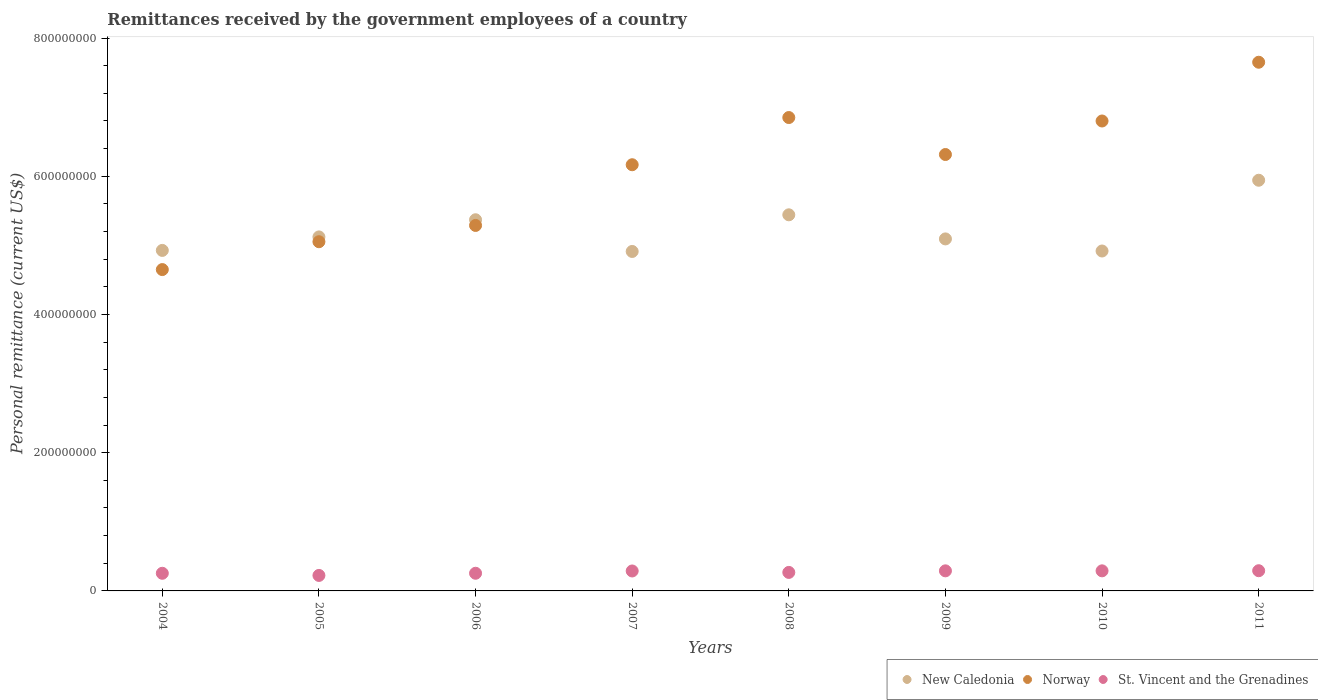How many different coloured dotlines are there?
Keep it short and to the point. 3. Is the number of dotlines equal to the number of legend labels?
Ensure brevity in your answer.  Yes. What is the remittances received by the government employees in New Caledonia in 2005?
Offer a very short reply. 5.12e+08. Across all years, what is the maximum remittances received by the government employees in Norway?
Make the answer very short. 7.65e+08. Across all years, what is the minimum remittances received by the government employees in Norway?
Ensure brevity in your answer.  4.65e+08. What is the total remittances received by the government employees in Norway in the graph?
Your response must be concise. 4.88e+09. What is the difference between the remittances received by the government employees in New Caledonia in 2004 and that in 2006?
Keep it short and to the point. -4.44e+07. What is the difference between the remittances received by the government employees in St. Vincent and the Grenadines in 2011 and the remittances received by the government employees in Norway in 2010?
Make the answer very short. -6.51e+08. What is the average remittances received by the government employees in New Caledonia per year?
Keep it short and to the point. 5.22e+08. In the year 2004, what is the difference between the remittances received by the government employees in New Caledonia and remittances received by the government employees in Norway?
Give a very brief answer. 2.77e+07. What is the ratio of the remittances received by the government employees in New Caledonia in 2008 to that in 2011?
Make the answer very short. 0.92. Is the difference between the remittances received by the government employees in New Caledonia in 2004 and 2009 greater than the difference between the remittances received by the government employees in Norway in 2004 and 2009?
Your answer should be very brief. Yes. What is the difference between the highest and the second highest remittances received by the government employees in St. Vincent and the Grenadines?
Your response must be concise. 1.79e+05. What is the difference between the highest and the lowest remittances received by the government employees in New Caledonia?
Provide a succinct answer. 1.03e+08. In how many years, is the remittances received by the government employees in New Caledonia greater than the average remittances received by the government employees in New Caledonia taken over all years?
Keep it short and to the point. 3. Is the sum of the remittances received by the government employees in Norway in 2007 and 2011 greater than the maximum remittances received by the government employees in New Caledonia across all years?
Offer a very short reply. Yes. Is the remittances received by the government employees in New Caledonia strictly greater than the remittances received by the government employees in St. Vincent and the Grenadines over the years?
Give a very brief answer. Yes. Is the remittances received by the government employees in Norway strictly less than the remittances received by the government employees in New Caledonia over the years?
Your answer should be very brief. No. How many years are there in the graph?
Your response must be concise. 8. What is the difference between two consecutive major ticks on the Y-axis?
Your answer should be very brief. 2.00e+08. Are the values on the major ticks of Y-axis written in scientific E-notation?
Your answer should be compact. No. Does the graph contain any zero values?
Make the answer very short. No. Does the graph contain grids?
Offer a very short reply. No. Where does the legend appear in the graph?
Ensure brevity in your answer.  Bottom right. What is the title of the graph?
Ensure brevity in your answer.  Remittances received by the government employees of a country. Does "Panama" appear as one of the legend labels in the graph?
Offer a very short reply. No. What is the label or title of the X-axis?
Ensure brevity in your answer.  Years. What is the label or title of the Y-axis?
Ensure brevity in your answer.  Personal remittance (current US$). What is the Personal remittance (current US$) of New Caledonia in 2004?
Make the answer very short. 4.93e+08. What is the Personal remittance (current US$) in Norway in 2004?
Keep it short and to the point. 4.65e+08. What is the Personal remittance (current US$) of St. Vincent and the Grenadines in 2004?
Keep it short and to the point. 2.55e+07. What is the Personal remittance (current US$) of New Caledonia in 2005?
Ensure brevity in your answer.  5.12e+08. What is the Personal remittance (current US$) of Norway in 2005?
Provide a short and direct response. 5.05e+08. What is the Personal remittance (current US$) in St. Vincent and the Grenadines in 2005?
Your response must be concise. 2.24e+07. What is the Personal remittance (current US$) of New Caledonia in 2006?
Provide a short and direct response. 5.37e+08. What is the Personal remittance (current US$) of Norway in 2006?
Give a very brief answer. 5.29e+08. What is the Personal remittance (current US$) in St. Vincent and the Grenadines in 2006?
Your response must be concise. 2.56e+07. What is the Personal remittance (current US$) of New Caledonia in 2007?
Offer a very short reply. 4.91e+08. What is the Personal remittance (current US$) of Norway in 2007?
Your response must be concise. 6.17e+08. What is the Personal remittance (current US$) of St. Vincent and the Grenadines in 2007?
Your response must be concise. 2.89e+07. What is the Personal remittance (current US$) in New Caledonia in 2008?
Offer a very short reply. 5.44e+08. What is the Personal remittance (current US$) of Norway in 2008?
Your answer should be very brief. 6.85e+08. What is the Personal remittance (current US$) of St. Vincent and the Grenadines in 2008?
Your answer should be very brief. 2.68e+07. What is the Personal remittance (current US$) in New Caledonia in 2009?
Provide a succinct answer. 5.09e+08. What is the Personal remittance (current US$) in Norway in 2009?
Your answer should be compact. 6.31e+08. What is the Personal remittance (current US$) of St. Vincent and the Grenadines in 2009?
Keep it short and to the point. 2.91e+07. What is the Personal remittance (current US$) of New Caledonia in 2010?
Offer a terse response. 4.92e+08. What is the Personal remittance (current US$) of Norway in 2010?
Make the answer very short. 6.80e+08. What is the Personal remittance (current US$) of St. Vincent and the Grenadines in 2010?
Offer a terse response. 2.91e+07. What is the Personal remittance (current US$) of New Caledonia in 2011?
Your answer should be very brief. 5.94e+08. What is the Personal remittance (current US$) of Norway in 2011?
Your answer should be compact. 7.65e+08. What is the Personal remittance (current US$) in St. Vincent and the Grenadines in 2011?
Provide a succinct answer. 2.92e+07. Across all years, what is the maximum Personal remittance (current US$) of New Caledonia?
Give a very brief answer. 5.94e+08. Across all years, what is the maximum Personal remittance (current US$) in Norway?
Your answer should be compact. 7.65e+08. Across all years, what is the maximum Personal remittance (current US$) in St. Vincent and the Grenadines?
Make the answer very short. 2.92e+07. Across all years, what is the minimum Personal remittance (current US$) of New Caledonia?
Keep it short and to the point. 4.91e+08. Across all years, what is the minimum Personal remittance (current US$) in Norway?
Ensure brevity in your answer.  4.65e+08. Across all years, what is the minimum Personal remittance (current US$) of St. Vincent and the Grenadines?
Your answer should be compact. 2.24e+07. What is the total Personal remittance (current US$) of New Caledonia in the graph?
Keep it short and to the point. 4.17e+09. What is the total Personal remittance (current US$) in Norway in the graph?
Offer a very short reply. 4.88e+09. What is the total Personal remittance (current US$) in St. Vincent and the Grenadines in the graph?
Give a very brief answer. 2.16e+08. What is the difference between the Personal remittance (current US$) of New Caledonia in 2004 and that in 2005?
Provide a short and direct response. -1.95e+07. What is the difference between the Personal remittance (current US$) in Norway in 2004 and that in 2005?
Ensure brevity in your answer.  -4.03e+07. What is the difference between the Personal remittance (current US$) of St. Vincent and the Grenadines in 2004 and that in 2005?
Your answer should be compact. 3.10e+06. What is the difference between the Personal remittance (current US$) of New Caledonia in 2004 and that in 2006?
Offer a terse response. -4.44e+07. What is the difference between the Personal remittance (current US$) of Norway in 2004 and that in 2006?
Provide a succinct answer. -6.39e+07. What is the difference between the Personal remittance (current US$) in St. Vincent and the Grenadines in 2004 and that in 2006?
Your response must be concise. -3.93e+04. What is the difference between the Personal remittance (current US$) of New Caledonia in 2004 and that in 2007?
Keep it short and to the point. 1.52e+06. What is the difference between the Personal remittance (current US$) in Norway in 2004 and that in 2007?
Give a very brief answer. -1.52e+08. What is the difference between the Personal remittance (current US$) of St. Vincent and the Grenadines in 2004 and that in 2007?
Provide a succinct answer. -3.35e+06. What is the difference between the Personal remittance (current US$) in New Caledonia in 2004 and that in 2008?
Ensure brevity in your answer.  -5.15e+07. What is the difference between the Personal remittance (current US$) of Norway in 2004 and that in 2008?
Your answer should be compact. -2.20e+08. What is the difference between the Personal remittance (current US$) of St. Vincent and the Grenadines in 2004 and that in 2008?
Your response must be concise. -1.26e+06. What is the difference between the Personal remittance (current US$) of New Caledonia in 2004 and that in 2009?
Provide a short and direct response. -1.66e+07. What is the difference between the Personal remittance (current US$) in Norway in 2004 and that in 2009?
Keep it short and to the point. -1.66e+08. What is the difference between the Personal remittance (current US$) in St. Vincent and the Grenadines in 2004 and that in 2009?
Provide a short and direct response. -3.54e+06. What is the difference between the Personal remittance (current US$) of New Caledonia in 2004 and that in 2010?
Provide a short and direct response. 8.64e+05. What is the difference between the Personal remittance (current US$) of Norway in 2004 and that in 2010?
Provide a short and direct response. -2.15e+08. What is the difference between the Personal remittance (current US$) in St. Vincent and the Grenadines in 2004 and that in 2010?
Give a very brief answer. -3.54e+06. What is the difference between the Personal remittance (current US$) in New Caledonia in 2004 and that in 2011?
Make the answer very short. -1.02e+08. What is the difference between the Personal remittance (current US$) in Norway in 2004 and that in 2011?
Your answer should be compact. -3.00e+08. What is the difference between the Personal remittance (current US$) of St. Vincent and the Grenadines in 2004 and that in 2011?
Ensure brevity in your answer.  -3.72e+06. What is the difference between the Personal remittance (current US$) in New Caledonia in 2005 and that in 2006?
Your answer should be very brief. -2.48e+07. What is the difference between the Personal remittance (current US$) in Norway in 2005 and that in 2006?
Offer a very short reply. -2.36e+07. What is the difference between the Personal remittance (current US$) in St. Vincent and the Grenadines in 2005 and that in 2006?
Your answer should be very brief. -3.14e+06. What is the difference between the Personal remittance (current US$) in New Caledonia in 2005 and that in 2007?
Offer a terse response. 2.10e+07. What is the difference between the Personal remittance (current US$) in Norway in 2005 and that in 2007?
Keep it short and to the point. -1.11e+08. What is the difference between the Personal remittance (current US$) of St. Vincent and the Grenadines in 2005 and that in 2007?
Provide a succinct answer. -6.45e+06. What is the difference between the Personal remittance (current US$) of New Caledonia in 2005 and that in 2008?
Offer a terse response. -3.20e+07. What is the difference between the Personal remittance (current US$) in Norway in 2005 and that in 2008?
Ensure brevity in your answer.  -1.80e+08. What is the difference between the Personal remittance (current US$) of St. Vincent and the Grenadines in 2005 and that in 2008?
Give a very brief answer. -4.36e+06. What is the difference between the Personal remittance (current US$) in New Caledonia in 2005 and that in 2009?
Your answer should be compact. 2.88e+06. What is the difference between the Personal remittance (current US$) in Norway in 2005 and that in 2009?
Keep it short and to the point. -1.26e+08. What is the difference between the Personal remittance (current US$) in St. Vincent and the Grenadines in 2005 and that in 2009?
Your answer should be very brief. -6.64e+06. What is the difference between the Personal remittance (current US$) in New Caledonia in 2005 and that in 2010?
Keep it short and to the point. 2.04e+07. What is the difference between the Personal remittance (current US$) of Norway in 2005 and that in 2010?
Your answer should be very brief. -1.75e+08. What is the difference between the Personal remittance (current US$) of St. Vincent and the Grenadines in 2005 and that in 2010?
Provide a succinct answer. -6.64e+06. What is the difference between the Personal remittance (current US$) in New Caledonia in 2005 and that in 2011?
Your answer should be compact. -8.20e+07. What is the difference between the Personal remittance (current US$) in Norway in 2005 and that in 2011?
Provide a short and direct response. -2.60e+08. What is the difference between the Personal remittance (current US$) in St. Vincent and the Grenadines in 2005 and that in 2011?
Keep it short and to the point. -6.82e+06. What is the difference between the Personal remittance (current US$) of New Caledonia in 2006 and that in 2007?
Offer a terse response. 4.59e+07. What is the difference between the Personal remittance (current US$) in Norway in 2006 and that in 2007?
Offer a terse response. -8.78e+07. What is the difference between the Personal remittance (current US$) in St. Vincent and the Grenadines in 2006 and that in 2007?
Give a very brief answer. -3.31e+06. What is the difference between the Personal remittance (current US$) of New Caledonia in 2006 and that in 2008?
Offer a terse response. -7.16e+06. What is the difference between the Personal remittance (current US$) of Norway in 2006 and that in 2008?
Your answer should be compact. -1.56e+08. What is the difference between the Personal remittance (current US$) of St. Vincent and the Grenadines in 2006 and that in 2008?
Provide a succinct answer. -1.22e+06. What is the difference between the Personal remittance (current US$) in New Caledonia in 2006 and that in 2009?
Offer a terse response. 2.77e+07. What is the difference between the Personal remittance (current US$) in Norway in 2006 and that in 2009?
Your answer should be compact. -1.03e+08. What is the difference between the Personal remittance (current US$) in St. Vincent and the Grenadines in 2006 and that in 2009?
Ensure brevity in your answer.  -3.50e+06. What is the difference between the Personal remittance (current US$) of New Caledonia in 2006 and that in 2010?
Provide a short and direct response. 4.52e+07. What is the difference between the Personal remittance (current US$) of Norway in 2006 and that in 2010?
Provide a short and direct response. -1.51e+08. What is the difference between the Personal remittance (current US$) in St. Vincent and the Grenadines in 2006 and that in 2010?
Keep it short and to the point. -3.50e+06. What is the difference between the Personal remittance (current US$) in New Caledonia in 2006 and that in 2011?
Provide a short and direct response. -5.72e+07. What is the difference between the Personal remittance (current US$) of Norway in 2006 and that in 2011?
Offer a terse response. -2.36e+08. What is the difference between the Personal remittance (current US$) of St. Vincent and the Grenadines in 2006 and that in 2011?
Offer a terse response. -3.68e+06. What is the difference between the Personal remittance (current US$) in New Caledonia in 2007 and that in 2008?
Provide a short and direct response. -5.30e+07. What is the difference between the Personal remittance (current US$) of Norway in 2007 and that in 2008?
Your answer should be very brief. -6.83e+07. What is the difference between the Personal remittance (current US$) of St. Vincent and the Grenadines in 2007 and that in 2008?
Make the answer very short. 2.09e+06. What is the difference between the Personal remittance (current US$) in New Caledonia in 2007 and that in 2009?
Provide a short and direct response. -1.82e+07. What is the difference between the Personal remittance (current US$) of Norway in 2007 and that in 2009?
Give a very brief answer. -1.48e+07. What is the difference between the Personal remittance (current US$) of St. Vincent and the Grenadines in 2007 and that in 2009?
Provide a succinct answer. -1.92e+05. What is the difference between the Personal remittance (current US$) in New Caledonia in 2007 and that in 2010?
Your answer should be compact. -6.58e+05. What is the difference between the Personal remittance (current US$) of Norway in 2007 and that in 2010?
Your answer should be very brief. -6.33e+07. What is the difference between the Personal remittance (current US$) of St. Vincent and the Grenadines in 2007 and that in 2010?
Your answer should be compact. -1.90e+05. What is the difference between the Personal remittance (current US$) in New Caledonia in 2007 and that in 2011?
Offer a terse response. -1.03e+08. What is the difference between the Personal remittance (current US$) of Norway in 2007 and that in 2011?
Your answer should be very brief. -1.48e+08. What is the difference between the Personal remittance (current US$) in St. Vincent and the Grenadines in 2007 and that in 2011?
Offer a very short reply. -3.71e+05. What is the difference between the Personal remittance (current US$) in New Caledonia in 2008 and that in 2009?
Your answer should be compact. 3.49e+07. What is the difference between the Personal remittance (current US$) in Norway in 2008 and that in 2009?
Provide a succinct answer. 5.35e+07. What is the difference between the Personal remittance (current US$) in St. Vincent and the Grenadines in 2008 and that in 2009?
Provide a succinct answer. -2.28e+06. What is the difference between the Personal remittance (current US$) of New Caledonia in 2008 and that in 2010?
Your answer should be very brief. 5.24e+07. What is the difference between the Personal remittance (current US$) of Norway in 2008 and that in 2010?
Your answer should be very brief. 5.00e+06. What is the difference between the Personal remittance (current US$) of St. Vincent and the Grenadines in 2008 and that in 2010?
Your answer should be very brief. -2.28e+06. What is the difference between the Personal remittance (current US$) in New Caledonia in 2008 and that in 2011?
Ensure brevity in your answer.  -5.00e+07. What is the difference between the Personal remittance (current US$) of Norway in 2008 and that in 2011?
Offer a terse response. -8.00e+07. What is the difference between the Personal remittance (current US$) in St. Vincent and the Grenadines in 2008 and that in 2011?
Give a very brief answer. -2.46e+06. What is the difference between the Personal remittance (current US$) of New Caledonia in 2009 and that in 2010?
Ensure brevity in your answer.  1.75e+07. What is the difference between the Personal remittance (current US$) in Norway in 2009 and that in 2010?
Ensure brevity in your answer.  -4.85e+07. What is the difference between the Personal remittance (current US$) in St. Vincent and the Grenadines in 2009 and that in 2010?
Offer a terse response. 1473.7. What is the difference between the Personal remittance (current US$) of New Caledonia in 2009 and that in 2011?
Your response must be concise. -8.49e+07. What is the difference between the Personal remittance (current US$) of Norway in 2009 and that in 2011?
Your answer should be very brief. -1.34e+08. What is the difference between the Personal remittance (current US$) of St. Vincent and the Grenadines in 2009 and that in 2011?
Your answer should be compact. -1.79e+05. What is the difference between the Personal remittance (current US$) of New Caledonia in 2010 and that in 2011?
Your answer should be compact. -1.02e+08. What is the difference between the Personal remittance (current US$) of Norway in 2010 and that in 2011?
Offer a very short reply. -8.50e+07. What is the difference between the Personal remittance (current US$) in St. Vincent and the Grenadines in 2010 and that in 2011?
Offer a terse response. -1.81e+05. What is the difference between the Personal remittance (current US$) in New Caledonia in 2004 and the Personal remittance (current US$) in Norway in 2005?
Keep it short and to the point. -1.26e+07. What is the difference between the Personal remittance (current US$) of New Caledonia in 2004 and the Personal remittance (current US$) of St. Vincent and the Grenadines in 2005?
Keep it short and to the point. 4.70e+08. What is the difference between the Personal remittance (current US$) in Norway in 2004 and the Personal remittance (current US$) in St. Vincent and the Grenadines in 2005?
Offer a very short reply. 4.43e+08. What is the difference between the Personal remittance (current US$) of New Caledonia in 2004 and the Personal remittance (current US$) of Norway in 2006?
Offer a very short reply. -3.61e+07. What is the difference between the Personal remittance (current US$) in New Caledonia in 2004 and the Personal remittance (current US$) in St. Vincent and the Grenadines in 2006?
Your answer should be compact. 4.67e+08. What is the difference between the Personal remittance (current US$) in Norway in 2004 and the Personal remittance (current US$) in St. Vincent and the Grenadines in 2006?
Offer a terse response. 4.39e+08. What is the difference between the Personal remittance (current US$) in New Caledonia in 2004 and the Personal remittance (current US$) in Norway in 2007?
Make the answer very short. -1.24e+08. What is the difference between the Personal remittance (current US$) of New Caledonia in 2004 and the Personal remittance (current US$) of St. Vincent and the Grenadines in 2007?
Offer a terse response. 4.64e+08. What is the difference between the Personal remittance (current US$) in Norway in 2004 and the Personal remittance (current US$) in St. Vincent and the Grenadines in 2007?
Give a very brief answer. 4.36e+08. What is the difference between the Personal remittance (current US$) of New Caledonia in 2004 and the Personal remittance (current US$) of Norway in 2008?
Provide a succinct answer. -1.92e+08. What is the difference between the Personal remittance (current US$) in New Caledonia in 2004 and the Personal remittance (current US$) in St. Vincent and the Grenadines in 2008?
Provide a short and direct response. 4.66e+08. What is the difference between the Personal remittance (current US$) of Norway in 2004 and the Personal remittance (current US$) of St. Vincent and the Grenadines in 2008?
Your response must be concise. 4.38e+08. What is the difference between the Personal remittance (current US$) of New Caledonia in 2004 and the Personal remittance (current US$) of Norway in 2009?
Provide a short and direct response. -1.39e+08. What is the difference between the Personal remittance (current US$) in New Caledonia in 2004 and the Personal remittance (current US$) in St. Vincent and the Grenadines in 2009?
Provide a short and direct response. 4.64e+08. What is the difference between the Personal remittance (current US$) of Norway in 2004 and the Personal remittance (current US$) of St. Vincent and the Grenadines in 2009?
Your answer should be very brief. 4.36e+08. What is the difference between the Personal remittance (current US$) in New Caledonia in 2004 and the Personal remittance (current US$) in Norway in 2010?
Provide a succinct answer. -1.87e+08. What is the difference between the Personal remittance (current US$) in New Caledonia in 2004 and the Personal remittance (current US$) in St. Vincent and the Grenadines in 2010?
Offer a very short reply. 4.64e+08. What is the difference between the Personal remittance (current US$) of Norway in 2004 and the Personal remittance (current US$) of St. Vincent and the Grenadines in 2010?
Make the answer very short. 4.36e+08. What is the difference between the Personal remittance (current US$) of New Caledonia in 2004 and the Personal remittance (current US$) of Norway in 2011?
Ensure brevity in your answer.  -2.72e+08. What is the difference between the Personal remittance (current US$) in New Caledonia in 2004 and the Personal remittance (current US$) in St. Vincent and the Grenadines in 2011?
Your response must be concise. 4.63e+08. What is the difference between the Personal remittance (current US$) of Norway in 2004 and the Personal remittance (current US$) of St. Vincent and the Grenadines in 2011?
Keep it short and to the point. 4.36e+08. What is the difference between the Personal remittance (current US$) in New Caledonia in 2005 and the Personal remittance (current US$) in Norway in 2006?
Make the answer very short. -1.66e+07. What is the difference between the Personal remittance (current US$) of New Caledonia in 2005 and the Personal remittance (current US$) of St. Vincent and the Grenadines in 2006?
Ensure brevity in your answer.  4.87e+08. What is the difference between the Personal remittance (current US$) in Norway in 2005 and the Personal remittance (current US$) in St. Vincent and the Grenadines in 2006?
Your answer should be compact. 4.80e+08. What is the difference between the Personal remittance (current US$) of New Caledonia in 2005 and the Personal remittance (current US$) of Norway in 2007?
Your answer should be very brief. -1.04e+08. What is the difference between the Personal remittance (current US$) in New Caledonia in 2005 and the Personal remittance (current US$) in St. Vincent and the Grenadines in 2007?
Provide a short and direct response. 4.83e+08. What is the difference between the Personal remittance (current US$) of Norway in 2005 and the Personal remittance (current US$) of St. Vincent and the Grenadines in 2007?
Your answer should be compact. 4.76e+08. What is the difference between the Personal remittance (current US$) in New Caledonia in 2005 and the Personal remittance (current US$) in Norway in 2008?
Give a very brief answer. -1.73e+08. What is the difference between the Personal remittance (current US$) in New Caledonia in 2005 and the Personal remittance (current US$) in St. Vincent and the Grenadines in 2008?
Offer a terse response. 4.85e+08. What is the difference between the Personal remittance (current US$) of Norway in 2005 and the Personal remittance (current US$) of St. Vincent and the Grenadines in 2008?
Provide a succinct answer. 4.79e+08. What is the difference between the Personal remittance (current US$) in New Caledonia in 2005 and the Personal remittance (current US$) in Norway in 2009?
Offer a very short reply. -1.19e+08. What is the difference between the Personal remittance (current US$) of New Caledonia in 2005 and the Personal remittance (current US$) of St. Vincent and the Grenadines in 2009?
Offer a very short reply. 4.83e+08. What is the difference between the Personal remittance (current US$) in Norway in 2005 and the Personal remittance (current US$) in St. Vincent and the Grenadines in 2009?
Keep it short and to the point. 4.76e+08. What is the difference between the Personal remittance (current US$) of New Caledonia in 2005 and the Personal remittance (current US$) of Norway in 2010?
Ensure brevity in your answer.  -1.68e+08. What is the difference between the Personal remittance (current US$) in New Caledonia in 2005 and the Personal remittance (current US$) in St. Vincent and the Grenadines in 2010?
Provide a succinct answer. 4.83e+08. What is the difference between the Personal remittance (current US$) of Norway in 2005 and the Personal remittance (current US$) of St. Vincent and the Grenadines in 2010?
Provide a succinct answer. 4.76e+08. What is the difference between the Personal remittance (current US$) of New Caledonia in 2005 and the Personal remittance (current US$) of Norway in 2011?
Offer a terse response. -2.53e+08. What is the difference between the Personal remittance (current US$) in New Caledonia in 2005 and the Personal remittance (current US$) in St. Vincent and the Grenadines in 2011?
Offer a terse response. 4.83e+08. What is the difference between the Personal remittance (current US$) of Norway in 2005 and the Personal remittance (current US$) of St. Vincent and the Grenadines in 2011?
Your response must be concise. 4.76e+08. What is the difference between the Personal remittance (current US$) in New Caledonia in 2006 and the Personal remittance (current US$) in Norway in 2007?
Keep it short and to the point. -7.96e+07. What is the difference between the Personal remittance (current US$) in New Caledonia in 2006 and the Personal remittance (current US$) in St. Vincent and the Grenadines in 2007?
Your answer should be compact. 5.08e+08. What is the difference between the Personal remittance (current US$) of Norway in 2006 and the Personal remittance (current US$) of St. Vincent and the Grenadines in 2007?
Your answer should be very brief. 5.00e+08. What is the difference between the Personal remittance (current US$) in New Caledonia in 2006 and the Personal remittance (current US$) in Norway in 2008?
Make the answer very short. -1.48e+08. What is the difference between the Personal remittance (current US$) in New Caledonia in 2006 and the Personal remittance (current US$) in St. Vincent and the Grenadines in 2008?
Your answer should be very brief. 5.10e+08. What is the difference between the Personal remittance (current US$) of Norway in 2006 and the Personal remittance (current US$) of St. Vincent and the Grenadines in 2008?
Offer a terse response. 5.02e+08. What is the difference between the Personal remittance (current US$) in New Caledonia in 2006 and the Personal remittance (current US$) in Norway in 2009?
Give a very brief answer. -9.44e+07. What is the difference between the Personal remittance (current US$) in New Caledonia in 2006 and the Personal remittance (current US$) in St. Vincent and the Grenadines in 2009?
Make the answer very short. 5.08e+08. What is the difference between the Personal remittance (current US$) in Norway in 2006 and the Personal remittance (current US$) in St. Vincent and the Grenadines in 2009?
Keep it short and to the point. 5.00e+08. What is the difference between the Personal remittance (current US$) of New Caledonia in 2006 and the Personal remittance (current US$) of Norway in 2010?
Your response must be concise. -1.43e+08. What is the difference between the Personal remittance (current US$) in New Caledonia in 2006 and the Personal remittance (current US$) in St. Vincent and the Grenadines in 2010?
Your response must be concise. 5.08e+08. What is the difference between the Personal remittance (current US$) of Norway in 2006 and the Personal remittance (current US$) of St. Vincent and the Grenadines in 2010?
Your answer should be very brief. 5.00e+08. What is the difference between the Personal remittance (current US$) of New Caledonia in 2006 and the Personal remittance (current US$) of Norway in 2011?
Offer a very short reply. -2.28e+08. What is the difference between the Personal remittance (current US$) of New Caledonia in 2006 and the Personal remittance (current US$) of St. Vincent and the Grenadines in 2011?
Keep it short and to the point. 5.08e+08. What is the difference between the Personal remittance (current US$) of Norway in 2006 and the Personal remittance (current US$) of St. Vincent and the Grenadines in 2011?
Offer a terse response. 5.00e+08. What is the difference between the Personal remittance (current US$) in New Caledonia in 2007 and the Personal remittance (current US$) in Norway in 2008?
Ensure brevity in your answer.  -1.94e+08. What is the difference between the Personal remittance (current US$) of New Caledonia in 2007 and the Personal remittance (current US$) of St. Vincent and the Grenadines in 2008?
Your answer should be very brief. 4.64e+08. What is the difference between the Personal remittance (current US$) of Norway in 2007 and the Personal remittance (current US$) of St. Vincent and the Grenadines in 2008?
Your answer should be compact. 5.90e+08. What is the difference between the Personal remittance (current US$) of New Caledonia in 2007 and the Personal remittance (current US$) of Norway in 2009?
Provide a succinct answer. -1.40e+08. What is the difference between the Personal remittance (current US$) of New Caledonia in 2007 and the Personal remittance (current US$) of St. Vincent and the Grenadines in 2009?
Offer a terse response. 4.62e+08. What is the difference between the Personal remittance (current US$) in Norway in 2007 and the Personal remittance (current US$) in St. Vincent and the Grenadines in 2009?
Keep it short and to the point. 5.88e+08. What is the difference between the Personal remittance (current US$) of New Caledonia in 2007 and the Personal remittance (current US$) of Norway in 2010?
Offer a terse response. -1.89e+08. What is the difference between the Personal remittance (current US$) of New Caledonia in 2007 and the Personal remittance (current US$) of St. Vincent and the Grenadines in 2010?
Your answer should be very brief. 4.62e+08. What is the difference between the Personal remittance (current US$) of Norway in 2007 and the Personal remittance (current US$) of St. Vincent and the Grenadines in 2010?
Make the answer very short. 5.88e+08. What is the difference between the Personal remittance (current US$) of New Caledonia in 2007 and the Personal remittance (current US$) of Norway in 2011?
Offer a terse response. -2.74e+08. What is the difference between the Personal remittance (current US$) of New Caledonia in 2007 and the Personal remittance (current US$) of St. Vincent and the Grenadines in 2011?
Your response must be concise. 4.62e+08. What is the difference between the Personal remittance (current US$) in Norway in 2007 and the Personal remittance (current US$) in St. Vincent and the Grenadines in 2011?
Provide a succinct answer. 5.87e+08. What is the difference between the Personal remittance (current US$) in New Caledonia in 2008 and the Personal remittance (current US$) in Norway in 2009?
Give a very brief answer. -8.72e+07. What is the difference between the Personal remittance (current US$) in New Caledonia in 2008 and the Personal remittance (current US$) in St. Vincent and the Grenadines in 2009?
Offer a terse response. 5.15e+08. What is the difference between the Personal remittance (current US$) in Norway in 2008 and the Personal remittance (current US$) in St. Vincent and the Grenadines in 2009?
Keep it short and to the point. 6.56e+08. What is the difference between the Personal remittance (current US$) of New Caledonia in 2008 and the Personal remittance (current US$) of Norway in 2010?
Make the answer very short. -1.36e+08. What is the difference between the Personal remittance (current US$) of New Caledonia in 2008 and the Personal remittance (current US$) of St. Vincent and the Grenadines in 2010?
Provide a succinct answer. 5.15e+08. What is the difference between the Personal remittance (current US$) of Norway in 2008 and the Personal remittance (current US$) of St. Vincent and the Grenadines in 2010?
Make the answer very short. 6.56e+08. What is the difference between the Personal remittance (current US$) in New Caledonia in 2008 and the Personal remittance (current US$) in Norway in 2011?
Offer a very short reply. -2.21e+08. What is the difference between the Personal remittance (current US$) in New Caledonia in 2008 and the Personal remittance (current US$) in St. Vincent and the Grenadines in 2011?
Your answer should be very brief. 5.15e+08. What is the difference between the Personal remittance (current US$) in Norway in 2008 and the Personal remittance (current US$) in St. Vincent and the Grenadines in 2011?
Offer a very short reply. 6.56e+08. What is the difference between the Personal remittance (current US$) in New Caledonia in 2009 and the Personal remittance (current US$) in Norway in 2010?
Ensure brevity in your answer.  -1.71e+08. What is the difference between the Personal remittance (current US$) in New Caledonia in 2009 and the Personal remittance (current US$) in St. Vincent and the Grenadines in 2010?
Your answer should be very brief. 4.80e+08. What is the difference between the Personal remittance (current US$) of Norway in 2009 and the Personal remittance (current US$) of St. Vincent and the Grenadines in 2010?
Your response must be concise. 6.02e+08. What is the difference between the Personal remittance (current US$) of New Caledonia in 2009 and the Personal remittance (current US$) of Norway in 2011?
Offer a terse response. -2.56e+08. What is the difference between the Personal remittance (current US$) in New Caledonia in 2009 and the Personal remittance (current US$) in St. Vincent and the Grenadines in 2011?
Offer a very short reply. 4.80e+08. What is the difference between the Personal remittance (current US$) of Norway in 2009 and the Personal remittance (current US$) of St. Vincent and the Grenadines in 2011?
Your response must be concise. 6.02e+08. What is the difference between the Personal remittance (current US$) in New Caledonia in 2010 and the Personal remittance (current US$) in Norway in 2011?
Your answer should be compact. -2.73e+08. What is the difference between the Personal remittance (current US$) of New Caledonia in 2010 and the Personal remittance (current US$) of St. Vincent and the Grenadines in 2011?
Your answer should be very brief. 4.63e+08. What is the difference between the Personal remittance (current US$) of Norway in 2010 and the Personal remittance (current US$) of St. Vincent and the Grenadines in 2011?
Offer a terse response. 6.51e+08. What is the average Personal remittance (current US$) in New Caledonia per year?
Ensure brevity in your answer.  5.22e+08. What is the average Personal remittance (current US$) in Norway per year?
Keep it short and to the point. 6.10e+08. What is the average Personal remittance (current US$) of St. Vincent and the Grenadines per year?
Offer a terse response. 2.71e+07. In the year 2004, what is the difference between the Personal remittance (current US$) in New Caledonia and Personal remittance (current US$) in Norway?
Offer a very short reply. 2.77e+07. In the year 2004, what is the difference between the Personal remittance (current US$) of New Caledonia and Personal remittance (current US$) of St. Vincent and the Grenadines?
Offer a very short reply. 4.67e+08. In the year 2004, what is the difference between the Personal remittance (current US$) in Norway and Personal remittance (current US$) in St. Vincent and the Grenadines?
Your answer should be very brief. 4.39e+08. In the year 2005, what is the difference between the Personal remittance (current US$) in New Caledonia and Personal remittance (current US$) in Norway?
Make the answer very short. 6.95e+06. In the year 2005, what is the difference between the Personal remittance (current US$) in New Caledonia and Personal remittance (current US$) in St. Vincent and the Grenadines?
Provide a short and direct response. 4.90e+08. In the year 2005, what is the difference between the Personal remittance (current US$) of Norway and Personal remittance (current US$) of St. Vincent and the Grenadines?
Your response must be concise. 4.83e+08. In the year 2006, what is the difference between the Personal remittance (current US$) of New Caledonia and Personal remittance (current US$) of Norway?
Your answer should be compact. 8.23e+06. In the year 2006, what is the difference between the Personal remittance (current US$) in New Caledonia and Personal remittance (current US$) in St. Vincent and the Grenadines?
Your answer should be very brief. 5.12e+08. In the year 2006, what is the difference between the Personal remittance (current US$) of Norway and Personal remittance (current US$) of St. Vincent and the Grenadines?
Give a very brief answer. 5.03e+08. In the year 2007, what is the difference between the Personal remittance (current US$) in New Caledonia and Personal remittance (current US$) in Norway?
Make the answer very short. -1.25e+08. In the year 2007, what is the difference between the Personal remittance (current US$) in New Caledonia and Personal remittance (current US$) in St. Vincent and the Grenadines?
Provide a succinct answer. 4.62e+08. In the year 2007, what is the difference between the Personal remittance (current US$) in Norway and Personal remittance (current US$) in St. Vincent and the Grenadines?
Keep it short and to the point. 5.88e+08. In the year 2008, what is the difference between the Personal remittance (current US$) in New Caledonia and Personal remittance (current US$) in Norway?
Ensure brevity in your answer.  -1.41e+08. In the year 2008, what is the difference between the Personal remittance (current US$) in New Caledonia and Personal remittance (current US$) in St. Vincent and the Grenadines?
Provide a short and direct response. 5.17e+08. In the year 2008, what is the difference between the Personal remittance (current US$) in Norway and Personal remittance (current US$) in St. Vincent and the Grenadines?
Ensure brevity in your answer.  6.58e+08. In the year 2009, what is the difference between the Personal remittance (current US$) in New Caledonia and Personal remittance (current US$) in Norway?
Keep it short and to the point. -1.22e+08. In the year 2009, what is the difference between the Personal remittance (current US$) in New Caledonia and Personal remittance (current US$) in St. Vincent and the Grenadines?
Offer a terse response. 4.80e+08. In the year 2009, what is the difference between the Personal remittance (current US$) in Norway and Personal remittance (current US$) in St. Vincent and the Grenadines?
Your answer should be very brief. 6.02e+08. In the year 2010, what is the difference between the Personal remittance (current US$) in New Caledonia and Personal remittance (current US$) in Norway?
Give a very brief answer. -1.88e+08. In the year 2010, what is the difference between the Personal remittance (current US$) of New Caledonia and Personal remittance (current US$) of St. Vincent and the Grenadines?
Ensure brevity in your answer.  4.63e+08. In the year 2010, what is the difference between the Personal remittance (current US$) in Norway and Personal remittance (current US$) in St. Vincent and the Grenadines?
Your answer should be compact. 6.51e+08. In the year 2011, what is the difference between the Personal remittance (current US$) in New Caledonia and Personal remittance (current US$) in Norway?
Your response must be concise. -1.71e+08. In the year 2011, what is the difference between the Personal remittance (current US$) of New Caledonia and Personal remittance (current US$) of St. Vincent and the Grenadines?
Offer a very short reply. 5.65e+08. In the year 2011, what is the difference between the Personal remittance (current US$) of Norway and Personal remittance (current US$) of St. Vincent and the Grenadines?
Make the answer very short. 7.36e+08. What is the ratio of the Personal remittance (current US$) of New Caledonia in 2004 to that in 2005?
Offer a very short reply. 0.96. What is the ratio of the Personal remittance (current US$) of Norway in 2004 to that in 2005?
Provide a succinct answer. 0.92. What is the ratio of the Personal remittance (current US$) of St. Vincent and the Grenadines in 2004 to that in 2005?
Keep it short and to the point. 1.14. What is the ratio of the Personal remittance (current US$) of New Caledonia in 2004 to that in 2006?
Your answer should be very brief. 0.92. What is the ratio of the Personal remittance (current US$) of Norway in 2004 to that in 2006?
Provide a succinct answer. 0.88. What is the ratio of the Personal remittance (current US$) in St. Vincent and the Grenadines in 2004 to that in 2006?
Provide a succinct answer. 1. What is the ratio of the Personal remittance (current US$) in New Caledonia in 2004 to that in 2007?
Make the answer very short. 1. What is the ratio of the Personal remittance (current US$) of Norway in 2004 to that in 2007?
Your response must be concise. 0.75. What is the ratio of the Personal remittance (current US$) of St. Vincent and the Grenadines in 2004 to that in 2007?
Offer a terse response. 0.88. What is the ratio of the Personal remittance (current US$) of New Caledonia in 2004 to that in 2008?
Provide a succinct answer. 0.91. What is the ratio of the Personal remittance (current US$) in Norway in 2004 to that in 2008?
Your answer should be very brief. 0.68. What is the ratio of the Personal remittance (current US$) of St. Vincent and the Grenadines in 2004 to that in 2008?
Offer a very short reply. 0.95. What is the ratio of the Personal remittance (current US$) of New Caledonia in 2004 to that in 2009?
Offer a terse response. 0.97. What is the ratio of the Personal remittance (current US$) of Norway in 2004 to that in 2009?
Provide a short and direct response. 0.74. What is the ratio of the Personal remittance (current US$) of St. Vincent and the Grenadines in 2004 to that in 2009?
Give a very brief answer. 0.88. What is the ratio of the Personal remittance (current US$) in New Caledonia in 2004 to that in 2010?
Offer a very short reply. 1. What is the ratio of the Personal remittance (current US$) in Norway in 2004 to that in 2010?
Offer a very short reply. 0.68. What is the ratio of the Personal remittance (current US$) of St. Vincent and the Grenadines in 2004 to that in 2010?
Keep it short and to the point. 0.88. What is the ratio of the Personal remittance (current US$) of New Caledonia in 2004 to that in 2011?
Ensure brevity in your answer.  0.83. What is the ratio of the Personal remittance (current US$) in Norway in 2004 to that in 2011?
Provide a short and direct response. 0.61. What is the ratio of the Personal remittance (current US$) in St. Vincent and the Grenadines in 2004 to that in 2011?
Your response must be concise. 0.87. What is the ratio of the Personal remittance (current US$) in New Caledonia in 2005 to that in 2006?
Your response must be concise. 0.95. What is the ratio of the Personal remittance (current US$) of Norway in 2005 to that in 2006?
Provide a short and direct response. 0.96. What is the ratio of the Personal remittance (current US$) of St. Vincent and the Grenadines in 2005 to that in 2006?
Ensure brevity in your answer.  0.88. What is the ratio of the Personal remittance (current US$) in New Caledonia in 2005 to that in 2007?
Provide a short and direct response. 1.04. What is the ratio of the Personal remittance (current US$) in Norway in 2005 to that in 2007?
Your answer should be very brief. 0.82. What is the ratio of the Personal remittance (current US$) in St. Vincent and the Grenadines in 2005 to that in 2007?
Provide a short and direct response. 0.78. What is the ratio of the Personal remittance (current US$) of Norway in 2005 to that in 2008?
Ensure brevity in your answer.  0.74. What is the ratio of the Personal remittance (current US$) in St. Vincent and the Grenadines in 2005 to that in 2008?
Give a very brief answer. 0.84. What is the ratio of the Personal remittance (current US$) in New Caledonia in 2005 to that in 2009?
Offer a terse response. 1.01. What is the ratio of the Personal remittance (current US$) of Norway in 2005 to that in 2009?
Ensure brevity in your answer.  0.8. What is the ratio of the Personal remittance (current US$) in St. Vincent and the Grenadines in 2005 to that in 2009?
Ensure brevity in your answer.  0.77. What is the ratio of the Personal remittance (current US$) in New Caledonia in 2005 to that in 2010?
Ensure brevity in your answer.  1.04. What is the ratio of the Personal remittance (current US$) of Norway in 2005 to that in 2010?
Your response must be concise. 0.74. What is the ratio of the Personal remittance (current US$) of St. Vincent and the Grenadines in 2005 to that in 2010?
Offer a very short reply. 0.77. What is the ratio of the Personal remittance (current US$) in New Caledonia in 2005 to that in 2011?
Make the answer very short. 0.86. What is the ratio of the Personal remittance (current US$) of Norway in 2005 to that in 2011?
Offer a very short reply. 0.66. What is the ratio of the Personal remittance (current US$) in St. Vincent and the Grenadines in 2005 to that in 2011?
Keep it short and to the point. 0.77. What is the ratio of the Personal remittance (current US$) in New Caledonia in 2006 to that in 2007?
Offer a very short reply. 1.09. What is the ratio of the Personal remittance (current US$) of Norway in 2006 to that in 2007?
Provide a short and direct response. 0.86. What is the ratio of the Personal remittance (current US$) in St. Vincent and the Grenadines in 2006 to that in 2007?
Offer a very short reply. 0.89. What is the ratio of the Personal remittance (current US$) of Norway in 2006 to that in 2008?
Your answer should be compact. 0.77. What is the ratio of the Personal remittance (current US$) of St. Vincent and the Grenadines in 2006 to that in 2008?
Make the answer very short. 0.95. What is the ratio of the Personal remittance (current US$) of New Caledonia in 2006 to that in 2009?
Keep it short and to the point. 1.05. What is the ratio of the Personal remittance (current US$) in Norway in 2006 to that in 2009?
Keep it short and to the point. 0.84. What is the ratio of the Personal remittance (current US$) in St. Vincent and the Grenadines in 2006 to that in 2009?
Your answer should be compact. 0.88. What is the ratio of the Personal remittance (current US$) in New Caledonia in 2006 to that in 2010?
Ensure brevity in your answer.  1.09. What is the ratio of the Personal remittance (current US$) of Norway in 2006 to that in 2010?
Ensure brevity in your answer.  0.78. What is the ratio of the Personal remittance (current US$) of St. Vincent and the Grenadines in 2006 to that in 2010?
Your response must be concise. 0.88. What is the ratio of the Personal remittance (current US$) in New Caledonia in 2006 to that in 2011?
Provide a short and direct response. 0.9. What is the ratio of the Personal remittance (current US$) of Norway in 2006 to that in 2011?
Keep it short and to the point. 0.69. What is the ratio of the Personal remittance (current US$) in St. Vincent and the Grenadines in 2006 to that in 2011?
Offer a very short reply. 0.87. What is the ratio of the Personal remittance (current US$) in New Caledonia in 2007 to that in 2008?
Your answer should be compact. 0.9. What is the ratio of the Personal remittance (current US$) in Norway in 2007 to that in 2008?
Your response must be concise. 0.9. What is the ratio of the Personal remittance (current US$) of St. Vincent and the Grenadines in 2007 to that in 2008?
Give a very brief answer. 1.08. What is the ratio of the Personal remittance (current US$) in Norway in 2007 to that in 2009?
Offer a very short reply. 0.98. What is the ratio of the Personal remittance (current US$) of New Caledonia in 2007 to that in 2010?
Offer a terse response. 1. What is the ratio of the Personal remittance (current US$) of Norway in 2007 to that in 2010?
Your response must be concise. 0.91. What is the ratio of the Personal remittance (current US$) in St. Vincent and the Grenadines in 2007 to that in 2010?
Offer a very short reply. 0.99. What is the ratio of the Personal remittance (current US$) in New Caledonia in 2007 to that in 2011?
Provide a succinct answer. 0.83. What is the ratio of the Personal remittance (current US$) of Norway in 2007 to that in 2011?
Keep it short and to the point. 0.81. What is the ratio of the Personal remittance (current US$) of St. Vincent and the Grenadines in 2007 to that in 2011?
Your answer should be very brief. 0.99. What is the ratio of the Personal remittance (current US$) in New Caledonia in 2008 to that in 2009?
Your answer should be compact. 1.07. What is the ratio of the Personal remittance (current US$) of Norway in 2008 to that in 2009?
Ensure brevity in your answer.  1.08. What is the ratio of the Personal remittance (current US$) in St. Vincent and the Grenadines in 2008 to that in 2009?
Provide a succinct answer. 0.92. What is the ratio of the Personal remittance (current US$) of New Caledonia in 2008 to that in 2010?
Offer a very short reply. 1.11. What is the ratio of the Personal remittance (current US$) of Norway in 2008 to that in 2010?
Offer a very short reply. 1.01. What is the ratio of the Personal remittance (current US$) of St. Vincent and the Grenadines in 2008 to that in 2010?
Your response must be concise. 0.92. What is the ratio of the Personal remittance (current US$) of New Caledonia in 2008 to that in 2011?
Your response must be concise. 0.92. What is the ratio of the Personal remittance (current US$) in Norway in 2008 to that in 2011?
Keep it short and to the point. 0.9. What is the ratio of the Personal remittance (current US$) of St. Vincent and the Grenadines in 2008 to that in 2011?
Your answer should be very brief. 0.92. What is the ratio of the Personal remittance (current US$) in New Caledonia in 2009 to that in 2010?
Provide a succinct answer. 1.04. What is the ratio of the Personal remittance (current US$) of Norway in 2009 to that in 2010?
Keep it short and to the point. 0.93. What is the ratio of the Personal remittance (current US$) of New Caledonia in 2009 to that in 2011?
Your answer should be compact. 0.86. What is the ratio of the Personal remittance (current US$) in Norway in 2009 to that in 2011?
Your answer should be very brief. 0.83. What is the ratio of the Personal remittance (current US$) in New Caledonia in 2010 to that in 2011?
Offer a terse response. 0.83. What is the ratio of the Personal remittance (current US$) of St. Vincent and the Grenadines in 2010 to that in 2011?
Provide a succinct answer. 0.99. What is the difference between the highest and the second highest Personal remittance (current US$) in New Caledonia?
Offer a very short reply. 5.00e+07. What is the difference between the highest and the second highest Personal remittance (current US$) of Norway?
Offer a very short reply. 8.00e+07. What is the difference between the highest and the second highest Personal remittance (current US$) in St. Vincent and the Grenadines?
Your response must be concise. 1.79e+05. What is the difference between the highest and the lowest Personal remittance (current US$) in New Caledonia?
Your response must be concise. 1.03e+08. What is the difference between the highest and the lowest Personal remittance (current US$) of Norway?
Ensure brevity in your answer.  3.00e+08. What is the difference between the highest and the lowest Personal remittance (current US$) in St. Vincent and the Grenadines?
Make the answer very short. 6.82e+06. 